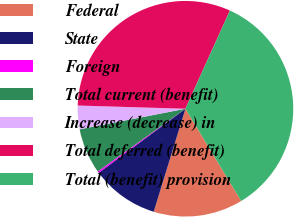<chart> <loc_0><loc_0><loc_500><loc_500><pie_chart><fcel>Federal<fcel>State<fcel>Foreign<fcel>Total current (benefit)<fcel>Increase (decrease) in<fcel>Total deferred (benefit)<fcel>Total (benefit) provision<nl><fcel>13.41%<fcel>10.12%<fcel>0.24%<fcel>6.83%<fcel>3.53%<fcel>31.29%<fcel>34.58%<nl></chart> 